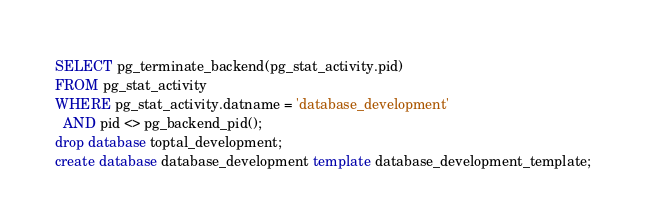<code> <loc_0><loc_0><loc_500><loc_500><_SQL_>SELECT pg_terminate_backend(pg_stat_activity.pid)
FROM pg_stat_activity
WHERE pg_stat_activity.datname = 'database_development'
  AND pid <> pg_backend_pid();
drop database toptal_development;
create database database_development template database_development_template;
</code> 